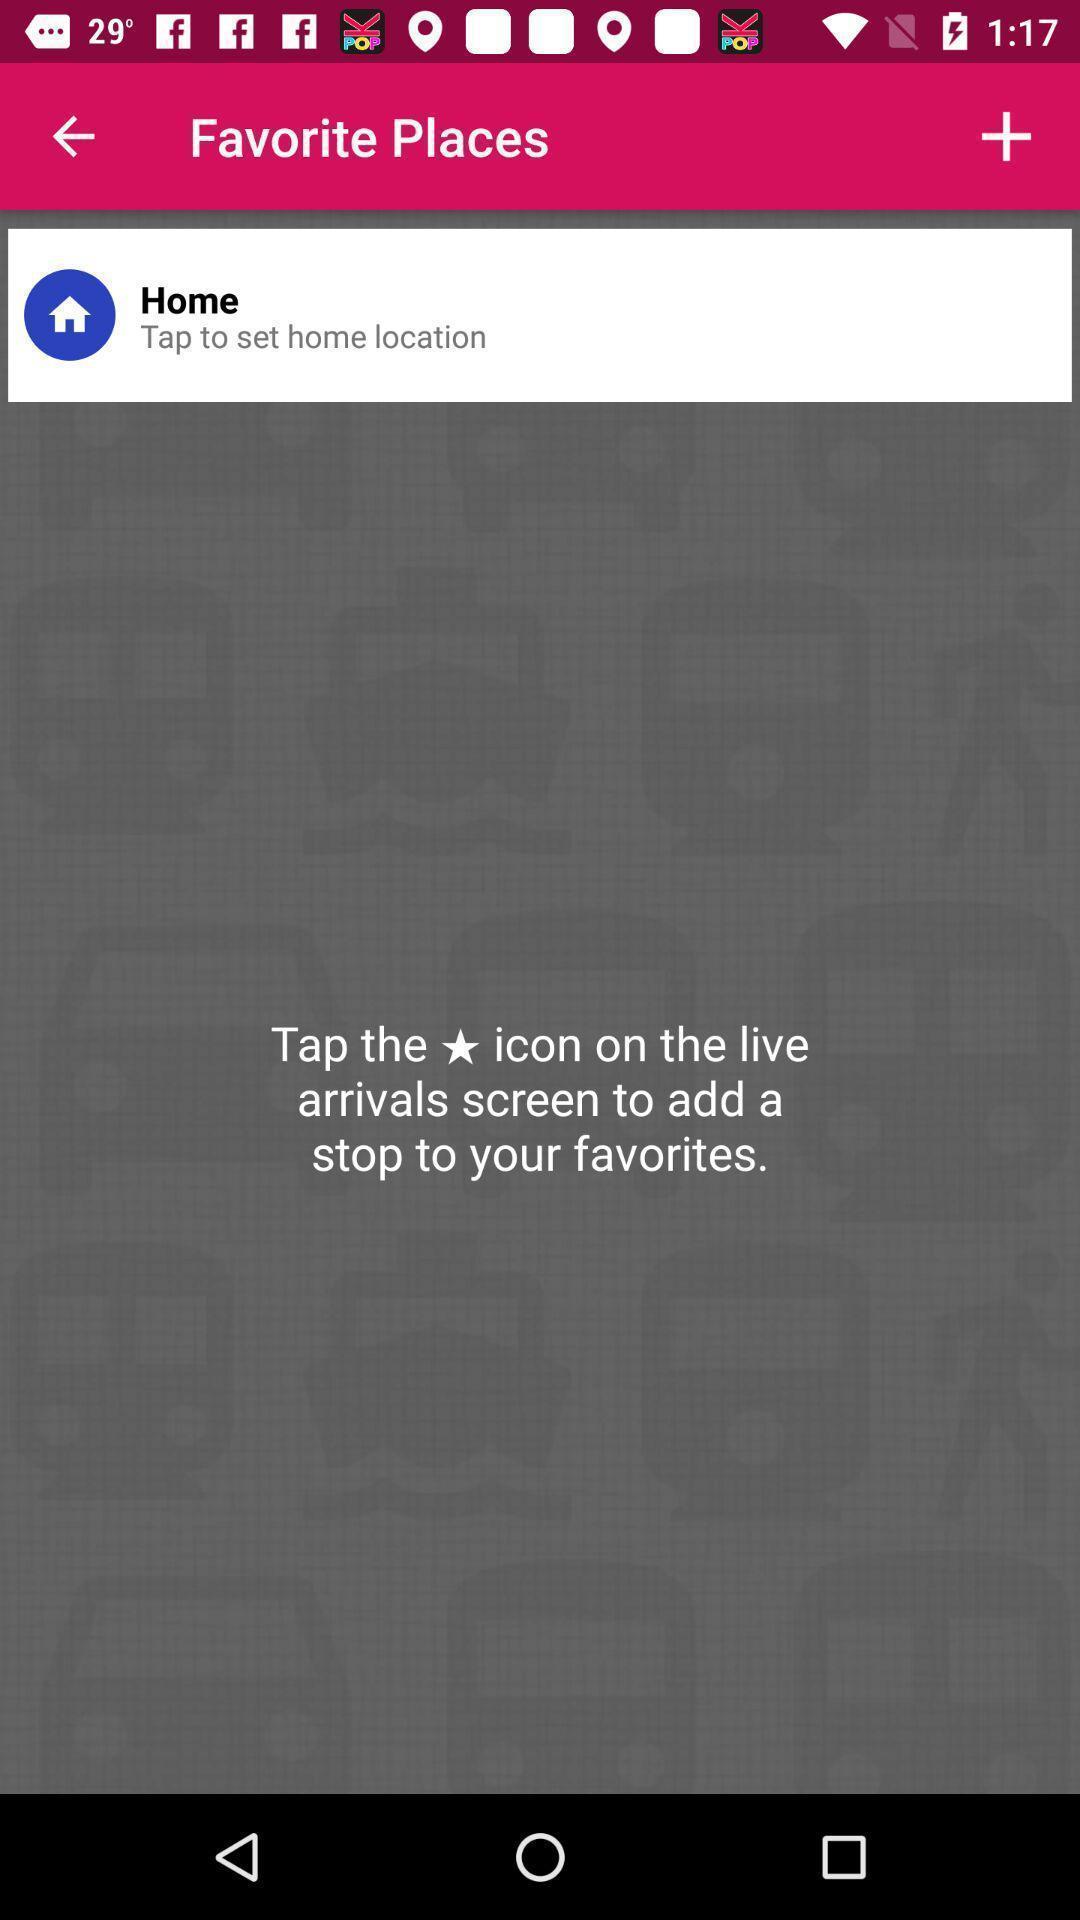Provide a description of this screenshot. Social app to know location. 